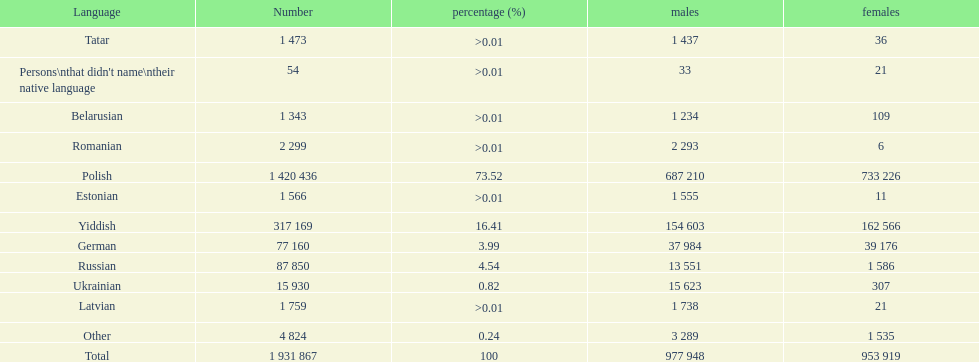Which language had the most number of people speaking it. Polish. 